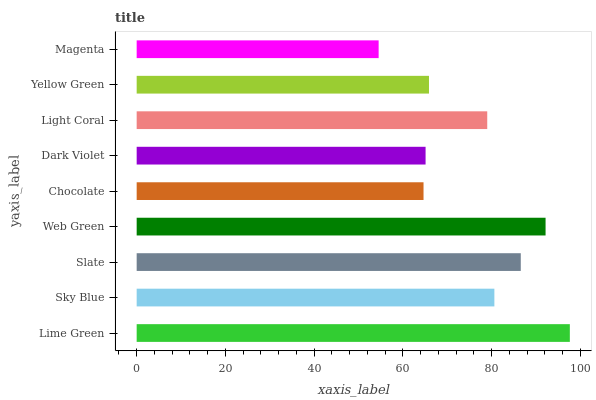Is Magenta the minimum?
Answer yes or no. Yes. Is Lime Green the maximum?
Answer yes or no. Yes. Is Sky Blue the minimum?
Answer yes or no. No. Is Sky Blue the maximum?
Answer yes or no. No. Is Lime Green greater than Sky Blue?
Answer yes or no. Yes. Is Sky Blue less than Lime Green?
Answer yes or no. Yes. Is Sky Blue greater than Lime Green?
Answer yes or no. No. Is Lime Green less than Sky Blue?
Answer yes or no. No. Is Light Coral the high median?
Answer yes or no. Yes. Is Light Coral the low median?
Answer yes or no. Yes. Is Chocolate the high median?
Answer yes or no. No. Is Chocolate the low median?
Answer yes or no. No. 